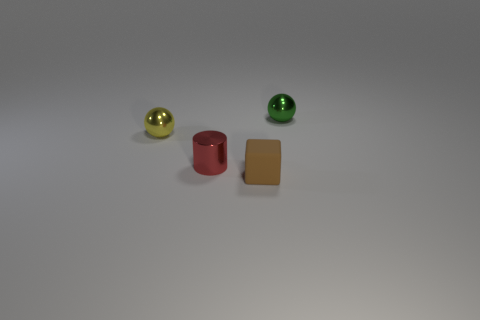There is a yellow metal object; how many small cylinders are in front of it?
Offer a very short reply. 1. Is the color of the tiny matte block the same as the metal cylinder?
Provide a short and direct response. No. The red thing that is the same material as the green ball is what shape?
Offer a terse response. Cylinder. Do the tiny metal object that is behind the tiny yellow ball and the small yellow thing have the same shape?
Provide a short and direct response. Yes. How many green objects are metallic balls or big shiny cylinders?
Offer a terse response. 1. Are there the same number of red objects that are behind the yellow shiny sphere and small red metal cylinders that are behind the red metallic cylinder?
Make the answer very short. Yes. What color is the tiny object that is behind the sphere that is in front of the tiny green thing that is behind the yellow shiny thing?
Provide a short and direct response. Green. Is there anything else of the same color as the metallic cylinder?
Make the answer very short. No. The red metal object that is the same size as the green thing is what shape?
Keep it short and to the point. Cylinder. Is the material of the tiny sphere that is to the right of the cylinder the same as the sphere that is to the left of the small matte block?
Your answer should be compact. Yes. 